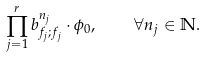Convert formula to latex. <formula><loc_0><loc_0><loc_500><loc_500>\prod _ { j = 1 } ^ { r } b _ { f _ { j } ; f _ { j } } ^ { n _ { j } } \cdot \phi _ { 0 } , \quad \forall n _ { j } \in \mathbb { N } .</formula> 